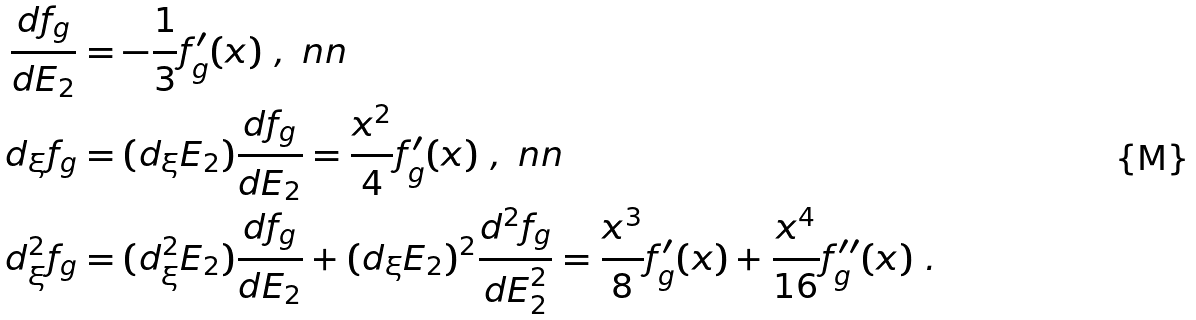Convert formula to latex. <formula><loc_0><loc_0><loc_500><loc_500>\frac { d f _ { g } } { d E _ { 2 } } & = - \frac { 1 } { 3 } f ^ { \prime } _ { g } ( x ) \ , \ n n \\ d _ { \xi } f _ { g } & = ( d _ { \xi } E _ { 2 } ) \frac { d f _ { g } } { d E _ { 2 } } = \frac { x ^ { 2 } } { 4 } f _ { g } ^ { \prime } ( x ) \ , \ n n \\ d ^ { 2 } _ { \xi } f _ { g } & = ( d _ { \xi } ^ { 2 } E _ { 2 } ) \frac { d f _ { g } } { d E _ { 2 } } + ( d _ { \xi } E _ { 2 } ) ^ { 2 } \frac { d ^ { 2 } f _ { g } } { d E _ { 2 } ^ { 2 } } = \frac { x ^ { 3 } } { 8 } f ^ { \prime } _ { g } ( x ) + \frac { x ^ { 4 } } { 1 6 } f ^ { \prime \prime } _ { g } ( x ) \ .</formula> 